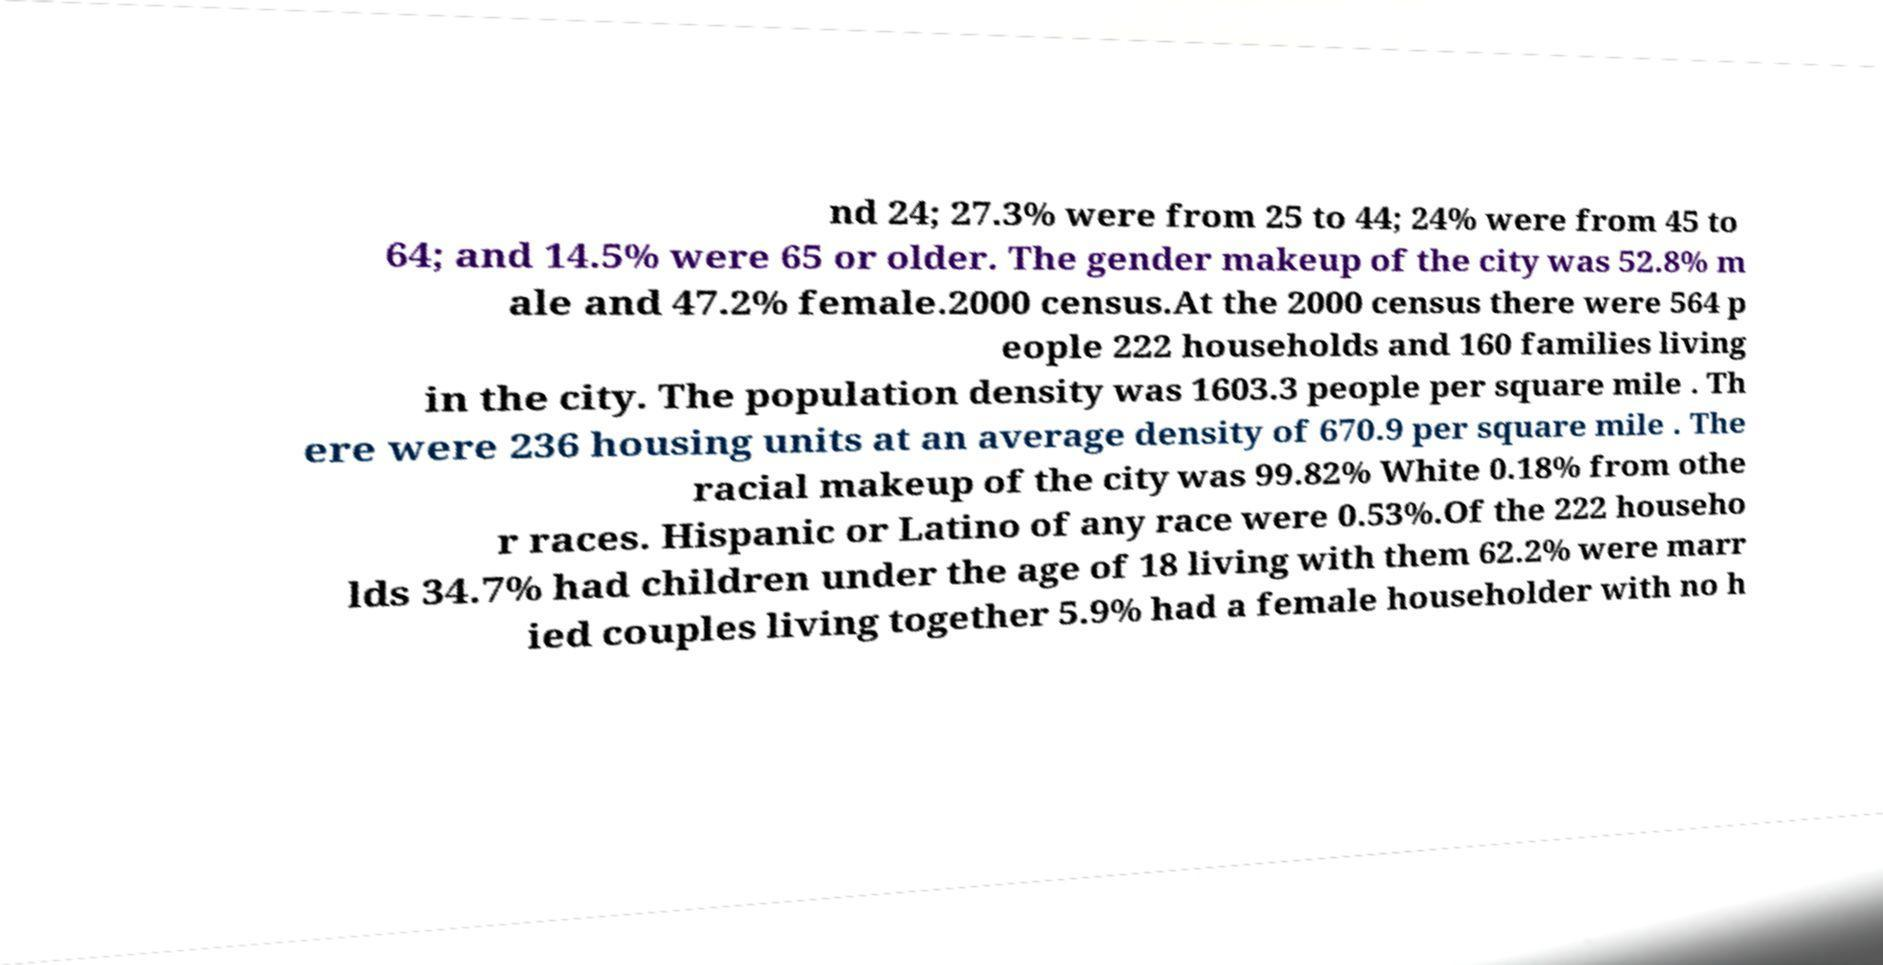What messages or text are displayed in this image? I need them in a readable, typed format. nd 24; 27.3% were from 25 to 44; 24% were from 45 to 64; and 14.5% were 65 or older. The gender makeup of the city was 52.8% m ale and 47.2% female.2000 census.At the 2000 census there were 564 p eople 222 households and 160 families living in the city. The population density was 1603.3 people per square mile . Th ere were 236 housing units at an average density of 670.9 per square mile . The racial makeup of the city was 99.82% White 0.18% from othe r races. Hispanic or Latino of any race were 0.53%.Of the 222 househo lds 34.7% had children under the age of 18 living with them 62.2% were marr ied couples living together 5.9% had a female householder with no h 